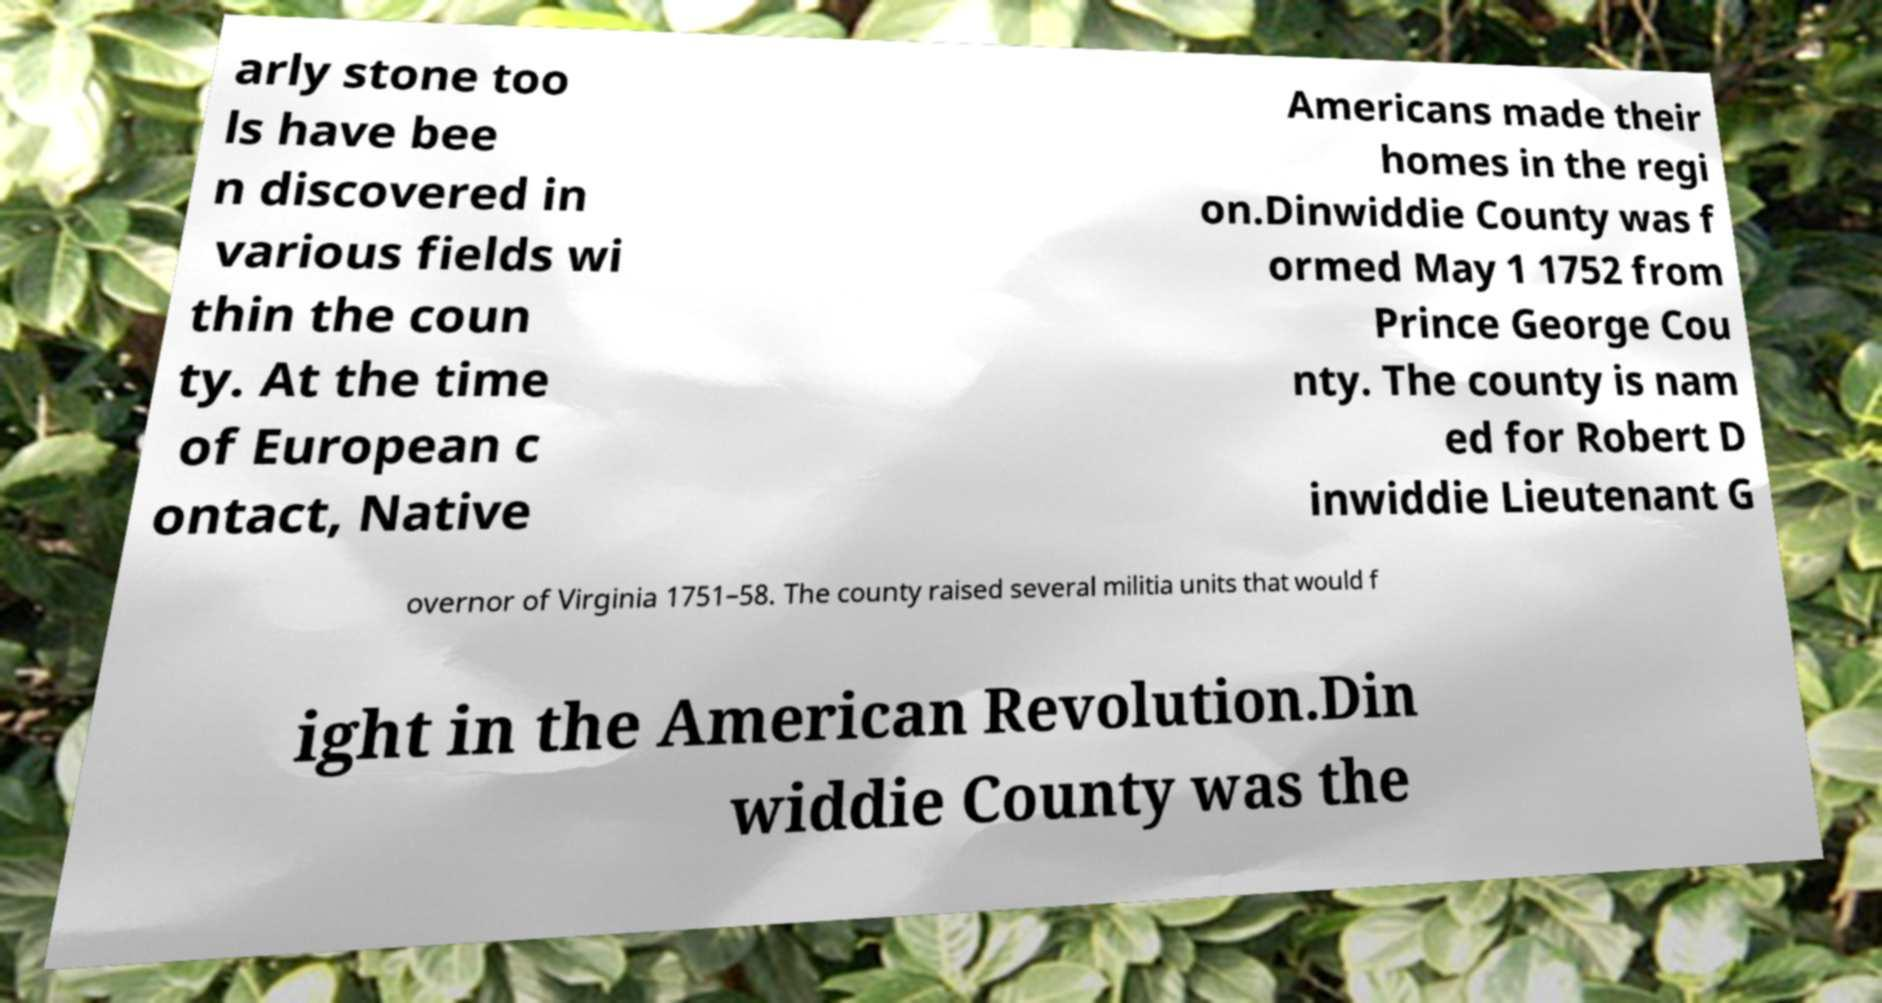There's text embedded in this image that I need extracted. Can you transcribe it verbatim? arly stone too ls have bee n discovered in various fields wi thin the coun ty. At the time of European c ontact, Native Americans made their homes in the regi on.Dinwiddie County was f ormed May 1 1752 from Prince George Cou nty. The county is nam ed for Robert D inwiddie Lieutenant G overnor of Virginia 1751–58. The county raised several militia units that would f ight in the American Revolution.Din widdie County was the 